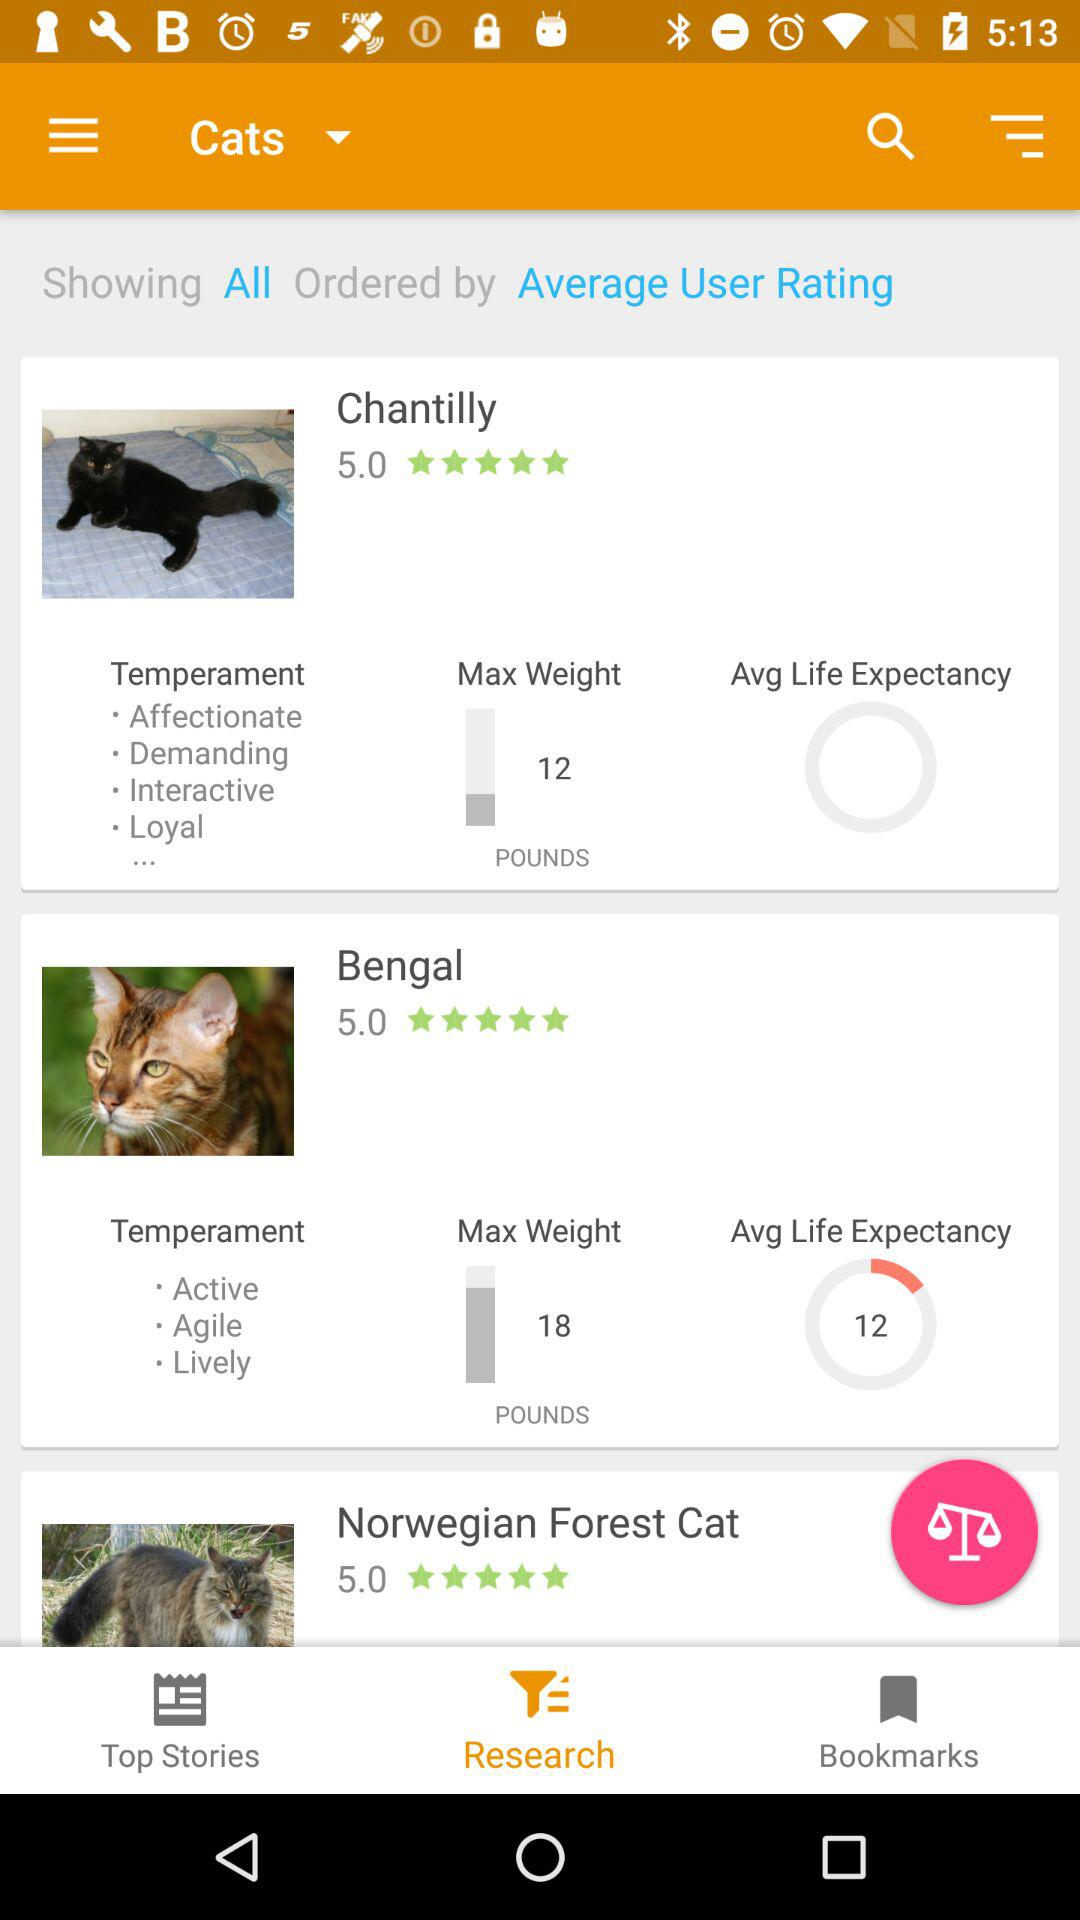What is the average life expectancy of Bengal cats? The average life expectancy of Bengal cats is 12 years. 